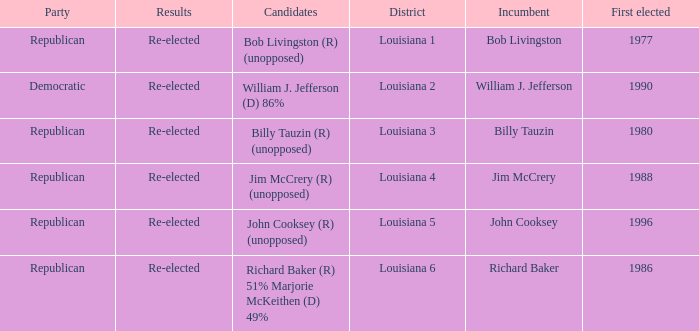What political party is william j. jefferson a member of? Democratic. Could you parse the entire table? {'header': ['Party', 'Results', 'Candidates', 'District', 'Incumbent', 'First elected'], 'rows': [['Republican', 'Re-elected', 'Bob Livingston (R) (unopposed)', 'Louisiana 1', 'Bob Livingston', '1977'], ['Democratic', 'Re-elected', 'William J. Jefferson (D) 86%', 'Louisiana 2', 'William J. Jefferson', '1990'], ['Republican', 'Re-elected', 'Billy Tauzin (R) (unopposed)', 'Louisiana 3', 'Billy Tauzin', '1980'], ['Republican', 'Re-elected', 'Jim McCrery (R) (unopposed)', 'Louisiana 4', 'Jim McCrery', '1988'], ['Republican', 'Re-elected', 'John Cooksey (R) (unopposed)', 'Louisiana 5', 'John Cooksey', '1996'], ['Republican', 'Re-elected', 'Richard Baker (R) 51% Marjorie McKeithen (D) 49%', 'Louisiana 6', 'Richard Baker', '1986']]} 